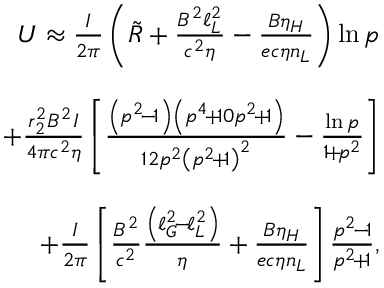<formula> <loc_0><loc_0><loc_500><loc_500>\begin{array} { r l r } & { U \approx \frac { I } { 2 \pi } \left ( \tilde { R } + \frac { B ^ { 2 } \ell _ { L } ^ { 2 } } { c ^ { 2 } \eta } - \frac { B \eta _ { H } } { e c \eta n _ { L } } \right ) \ln p } \\ & \\ & { \quad + \frac { r _ { 2 } ^ { 2 } B ^ { 2 } I } { 4 \pi c ^ { 2 } \eta } \left [ \frac { \left ( p ^ { 2 } \, - \, 1 \right ) \left ( p ^ { 4 } \, + \, 1 0 p ^ { 2 } \, + \, 1 \right ) } { 1 2 p ^ { 2 } \left ( p ^ { 2 } \, + \, 1 \right ) ^ { 2 } } - \frac { \ln p } { 1 \, + \, p ^ { 2 } } \right ] } \\ & \\ & { \quad + \frac { I } { 2 \pi } \left [ \frac { B ^ { 2 } } { c ^ { 2 } } \frac { \left ( \ell _ { G } ^ { 2 } \, - \, \ell _ { L } ^ { 2 } \right ) } { \eta } + \frac { B \eta _ { H } } { e c \eta n _ { L } } \right ] \frac { p ^ { 2 } \, - \, 1 } { p ^ { 2 } \, + \, 1 } , } \end{array}</formula> 